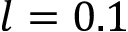<formula> <loc_0><loc_0><loc_500><loc_500>l = 0 . 1</formula> 